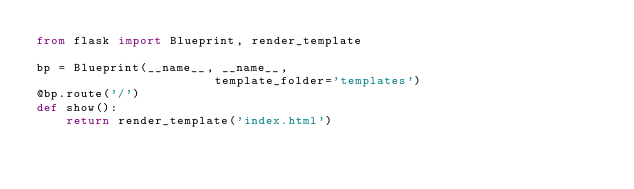<code> <loc_0><loc_0><loc_500><loc_500><_Python_>from flask import Blueprint, render_template

bp = Blueprint(__name__, __name__,
                        template_folder='templates')
@bp.route('/')
def show():
	return render_template('index.html')</code> 